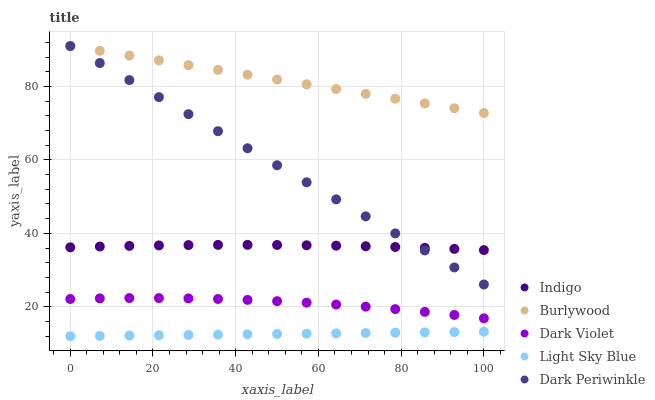Does Light Sky Blue have the minimum area under the curve?
Answer yes or no. Yes. Does Burlywood have the maximum area under the curve?
Answer yes or no. Yes. Does Indigo have the minimum area under the curve?
Answer yes or no. No. Does Indigo have the maximum area under the curve?
Answer yes or no. No. Is Light Sky Blue the smoothest?
Answer yes or no. Yes. Is Dark Violet the roughest?
Answer yes or no. Yes. Is Indigo the smoothest?
Answer yes or no. No. Is Indigo the roughest?
Answer yes or no. No. Does Light Sky Blue have the lowest value?
Answer yes or no. Yes. Does Indigo have the lowest value?
Answer yes or no. No. Does Dark Periwinkle have the highest value?
Answer yes or no. Yes. Does Indigo have the highest value?
Answer yes or no. No. Is Light Sky Blue less than Dark Violet?
Answer yes or no. Yes. Is Indigo greater than Light Sky Blue?
Answer yes or no. Yes. Does Dark Periwinkle intersect Burlywood?
Answer yes or no. Yes. Is Dark Periwinkle less than Burlywood?
Answer yes or no. No. Is Dark Periwinkle greater than Burlywood?
Answer yes or no. No. Does Light Sky Blue intersect Dark Violet?
Answer yes or no. No. 